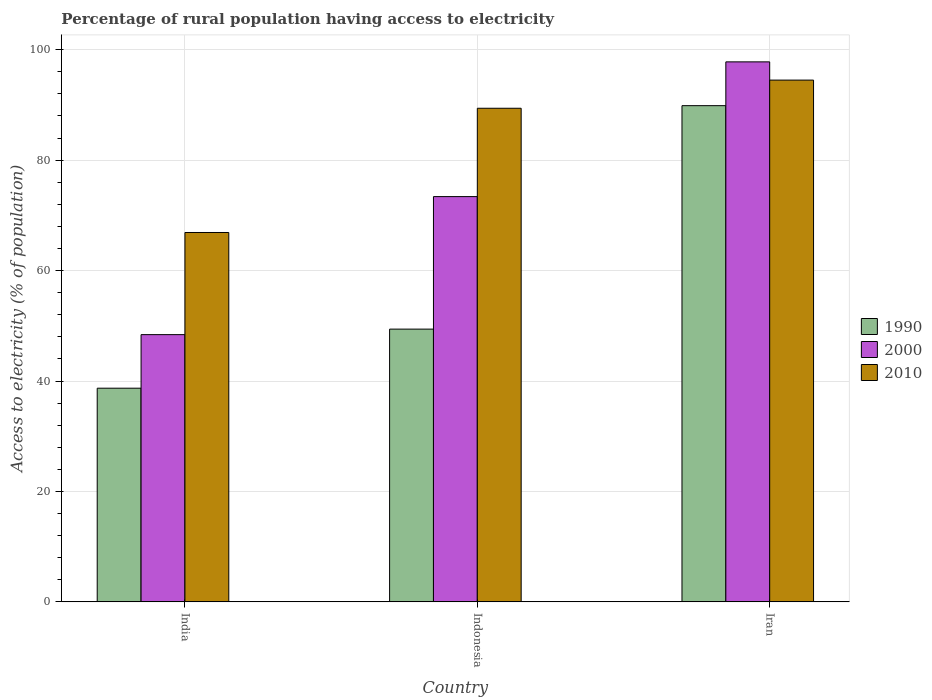How many different coloured bars are there?
Make the answer very short. 3. Are the number of bars per tick equal to the number of legend labels?
Provide a succinct answer. Yes. Are the number of bars on each tick of the X-axis equal?
Offer a very short reply. Yes. How many bars are there on the 3rd tick from the left?
Your answer should be very brief. 3. What is the label of the 3rd group of bars from the left?
Your answer should be compact. Iran. What is the percentage of rural population having access to electricity in 2010 in Indonesia?
Ensure brevity in your answer.  89.4. Across all countries, what is the maximum percentage of rural population having access to electricity in 1990?
Your response must be concise. 89.87. Across all countries, what is the minimum percentage of rural population having access to electricity in 2000?
Ensure brevity in your answer.  48.4. In which country was the percentage of rural population having access to electricity in 2010 maximum?
Offer a very short reply. Iran. What is the total percentage of rural population having access to electricity in 2000 in the graph?
Offer a very short reply. 219.6. What is the difference between the percentage of rural population having access to electricity in 1990 in India and that in Indonesia?
Offer a very short reply. -10.7. What is the difference between the percentage of rural population having access to electricity in 1990 in Iran and the percentage of rural population having access to electricity in 2010 in India?
Your answer should be compact. 22.97. What is the average percentage of rural population having access to electricity in 2000 per country?
Your answer should be compact. 73.2. What is the difference between the percentage of rural population having access to electricity of/in 2000 and percentage of rural population having access to electricity of/in 1990 in India?
Provide a short and direct response. 9.7. In how many countries, is the percentage of rural population having access to electricity in 2000 greater than 60 %?
Provide a short and direct response. 2. What is the ratio of the percentage of rural population having access to electricity in 2010 in India to that in Iran?
Your answer should be compact. 0.71. Is the percentage of rural population having access to electricity in 1990 in India less than that in Indonesia?
Offer a terse response. Yes. Is the difference between the percentage of rural population having access to electricity in 2000 in India and Iran greater than the difference between the percentage of rural population having access to electricity in 1990 in India and Iran?
Give a very brief answer. Yes. What is the difference between the highest and the second highest percentage of rural population having access to electricity in 2000?
Keep it short and to the point. -24.4. What is the difference between the highest and the lowest percentage of rural population having access to electricity in 1990?
Provide a short and direct response. 51.17. In how many countries, is the percentage of rural population having access to electricity in 2010 greater than the average percentage of rural population having access to electricity in 2010 taken over all countries?
Your answer should be very brief. 2. Is the sum of the percentage of rural population having access to electricity in 2000 in Indonesia and Iran greater than the maximum percentage of rural population having access to electricity in 2010 across all countries?
Give a very brief answer. Yes. What does the 2nd bar from the right in Iran represents?
Ensure brevity in your answer.  2000. Is it the case that in every country, the sum of the percentage of rural population having access to electricity in 1990 and percentage of rural population having access to electricity in 2010 is greater than the percentage of rural population having access to electricity in 2000?
Give a very brief answer. Yes. How many countries are there in the graph?
Provide a succinct answer. 3. What is the difference between two consecutive major ticks on the Y-axis?
Ensure brevity in your answer.  20. Are the values on the major ticks of Y-axis written in scientific E-notation?
Your response must be concise. No. Does the graph contain any zero values?
Give a very brief answer. No. Where does the legend appear in the graph?
Your answer should be very brief. Center right. How many legend labels are there?
Give a very brief answer. 3. What is the title of the graph?
Your response must be concise. Percentage of rural population having access to electricity. Does "1974" appear as one of the legend labels in the graph?
Offer a very short reply. No. What is the label or title of the Y-axis?
Your answer should be compact. Access to electricity (% of population). What is the Access to electricity (% of population) in 1990 in India?
Give a very brief answer. 38.7. What is the Access to electricity (% of population) in 2000 in India?
Your response must be concise. 48.4. What is the Access to electricity (% of population) of 2010 in India?
Your answer should be very brief. 66.9. What is the Access to electricity (% of population) in 1990 in Indonesia?
Your answer should be very brief. 49.4. What is the Access to electricity (% of population) in 2000 in Indonesia?
Give a very brief answer. 73.4. What is the Access to electricity (% of population) of 2010 in Indonesia?
Give a very brief answer. 89.4. What is the Access to electricity (% of population) of 1990 in Iran?
Keep it short and to the point. 89.87. What is the Access to electricity (% of population) in 2000 in Iran?
Offer a terse response. 97.8. What is the Access to electricity (% of population) in 2010 in Iran?
Give a very brief answer. 94.5. Across all countries, what is the maximum Access to electricity (% of population) in 1990?
Keep it short and to the point. 89.87. Across all countries, what is the maximum Access to electricity (% of population) in 2000?
Make the answer very short. 97.8. Across all countries, what is the maximum Access to electricity (% of population) of 2010?
Provide a succinct answer. 94.5. Across all countries, what is the minimum Access to electricity (% of population) of 1990?
Ensure brevity in your answer.  38.7. Across all countries, what is the minimum Access to electricity (% of population) in 2000?
Offer a very short reply. 48.4. Across all countries, what is the minimum Access to electricity (% of population) in 2010?
Ensure brevity in your answer.  66.9. What is the total Access to electricity (% of population) in 1990 in the graph?
Your answer should be compact. 177.97. What is the total Access to electricity (% of population) in 2000 in the graph?
Keep it short and to the point. 219.6. What is the total Access to electricity (% of population) in 2010 in the graph?
Give a very brief answer. 250.8. What is the difference between the Access to electricity (% of population) of 1990 in India and that in Indonesia?
Give a very brief answer. -10.7. What is the difference between the Access to electricity (% of population) of 2010 in India and that in Indonesia?
Provide a short and direct response. -22.5. What is the difference between the Access to electricity (% of population) of 1990 in India and that in Iran?
Your response must be concise. -51.17. What is the difference between the Access to electricity (% of population) of 2000 in India and that in Iran?
Keep it short and to the point. -49.4. What is the difference between the Access to electricity (% of population) in 2010 in India and that in Iran?
Your response must be concise. -27.6. What is the difference between the Access to electricity (% of population) in 1990 in Indonesia and that in Iran?
Your answer should be compact. -40.47. What is the difference between the Access to electricity (% of population) in 2000 in Indonesia and that in Iran?
Your answer should be very brief. -24.4. What is the difference between the Access to electricity (% of population) of 1990 in India and the Access to electricity (% of population) of 2000 in Indonesia?
Make the answer very short. -34.7. What is the difference between the Access to electricity (% of population) of 1990 in India and the Access to electricity (% of population) of 2010 in Indonesia?
Ensure brevity in your answer.  -50.7. What is the difference between the Access to electricity (% of population) in 2000 in India and the Access to electricity (% of population) in 2010 in Indonesia?
Give a very brief answer. -41. What is the difference between the Access to electricity (% of population) in 1990 in India and the Access to electricity (% of population) in 2000 in Iran?
Your answer should be compact. -59.1. What is the difference between the Access to electricity (% of population) of 1990 in India and the Access to electricity (% of population) of 2010 in Iran?
Offer a terse response. -55.8. What is the difference between the Access to electricity (% of population) in 2000 in India and the Access to electricity (% of population) in 2010 in Iran?
Make the answer very short. -46.1. What is the difference between the Access to electricity (% of population) of 1990 in Indonesia and the Access to electricity (% of population) of 2000 in Iran?
Give a very brief answer. -48.4. What is the difference between the Access to electricity (% of population) of 1990 in Indonesia and the Access to electricity (% of population) of 2010 in Iran?
Keep it short and to the point. -45.1. What is the difference between the Access to electricity (% of population) in 2000 in Indonesia and the Access to electricity (% of population) in 2010 in Iran?
Your answer should be very brief. -21.1. What is the average Access to electricity (% of population) of 1990 per country?
Your answer should be compact. 59.32. What is the average Access to electricity (% of population) of 2000 per country?
Your response must be concise. 73.2. What is the average Access to electricity (% of population) of 2010 per country?
Your answer should be very brief. 83.6. What is the difference between the Access to electricity (% of population) in 1990 and Access to electricity (% of population) in 2000 in India?
Your answer should be very brief. -9.7. What is the difference between the Access to electricity (% of population) in 1990 and Access to electricity (% of population) in 2010 in India?
Your answer should be compact. -28.2. What is the difference between the Access to electricity (% of population) in 2000 and Access to electricity (% of population) in 2010 in India?
Your response must be concise. -18.5. What is the difference between the Access to electricity (% of population) in 1990 and Access to electricity (% of population) in 2010 in Indonesia?
Your response must be concise. -40. What is the difference between the Access to electricity (% of population) of 2000 and Access to electricity (% of population) of 2010 in Indonesia?
Ensure brevity in your answer.  -16. What is the difference between the Access to electricity (% of population) in 1990 and Access to electricity (% of population) in 2000 in Iran?
Provide a succinct answer. -7.93. What is the difference between the Access to electricity (% of population) of 1990 and Access to electricity (% of population) of 2010 in Iran?
Offer a terse response. -4.63. What is the difference between the Access to electricity (% of population) of 2000 and Access to electricity (% of population) of 2010 in Iran?
Offer a very short reply. 3.3. What is the ratio of the Access to electricity (% of population) of 1990 in India to that in Indonesia?
Offer a terse response. 0.78. What is the ratio of the Access to electricity (% of population) in 2000 in India to that in Indonesia?
Ensure brevity in your answer.  0.66. What is the ratio of the Access to electricity (% of population) in 2010 in India to that in Indonesia?
Offer a very short reply. 0.75. What is the ratio of the Access to electricity (% of population) of 1990 in India to that in Iran?
Your response must be concise. 0.43. What is the ratio of the Access to electricity (% of population) of 2000 in India to that in Iran?
Give a very brief answer. 0.49. What is the ratio of the Access to electricity (% of population) in 2010 in India to that in Iran?
Give a very brief answer. 0.71. What is the ratio of the Access to electricity (% of population) in 1990 in Indonesia to that in Iran?
Ensure brevity in your answer.  0.55. What is the ratio of the Access to electricity (% of population) of 2000 in Indonesia to that in Iran?
Ensure brevity in your answer.  0.75. What is the ratio of the Access to electricity (% of population) of 2010 in Indonesia to that in Iran?
Your answer should be compact. 0.95. What is the difference between the highest and the second highest Access to electricity (% of population) in 1990?
Offer a terse response. 40.47. What is the difference between the highest and the second highest Access to electricity (% of population) of 2000?
Give a very brief answer. 24.4. What is the difference between the highest and the lowest Access to electricity (% of population) of 1990?
Offer a terse response. 51.17. What is the difference between the highest and the lowest Access to electricity (% of population) in 2000?
Offer a very short reply. 49.4. What is the difference between the highest and the lowest Access to electricity (% of population) in 2010?
Make the answer very short. 27.6. 